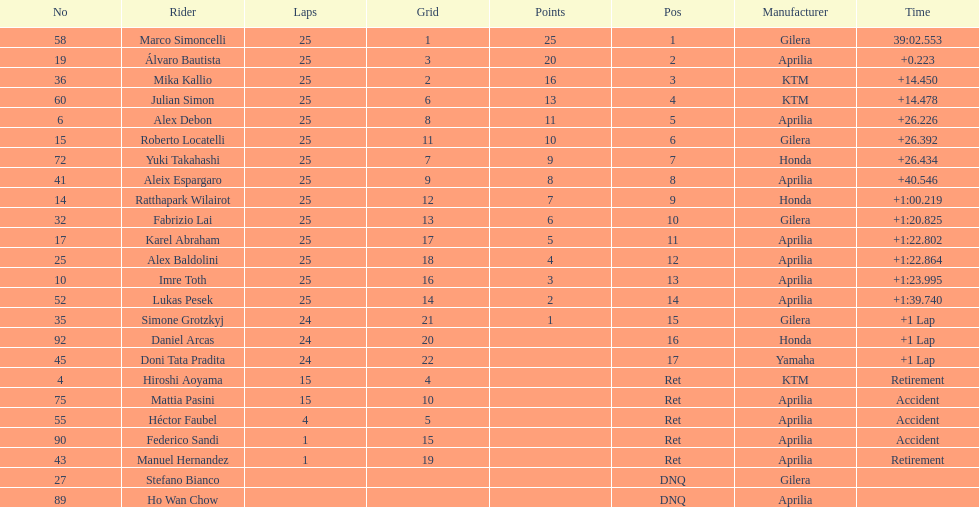The total amount of riders who did not qualify 2. 